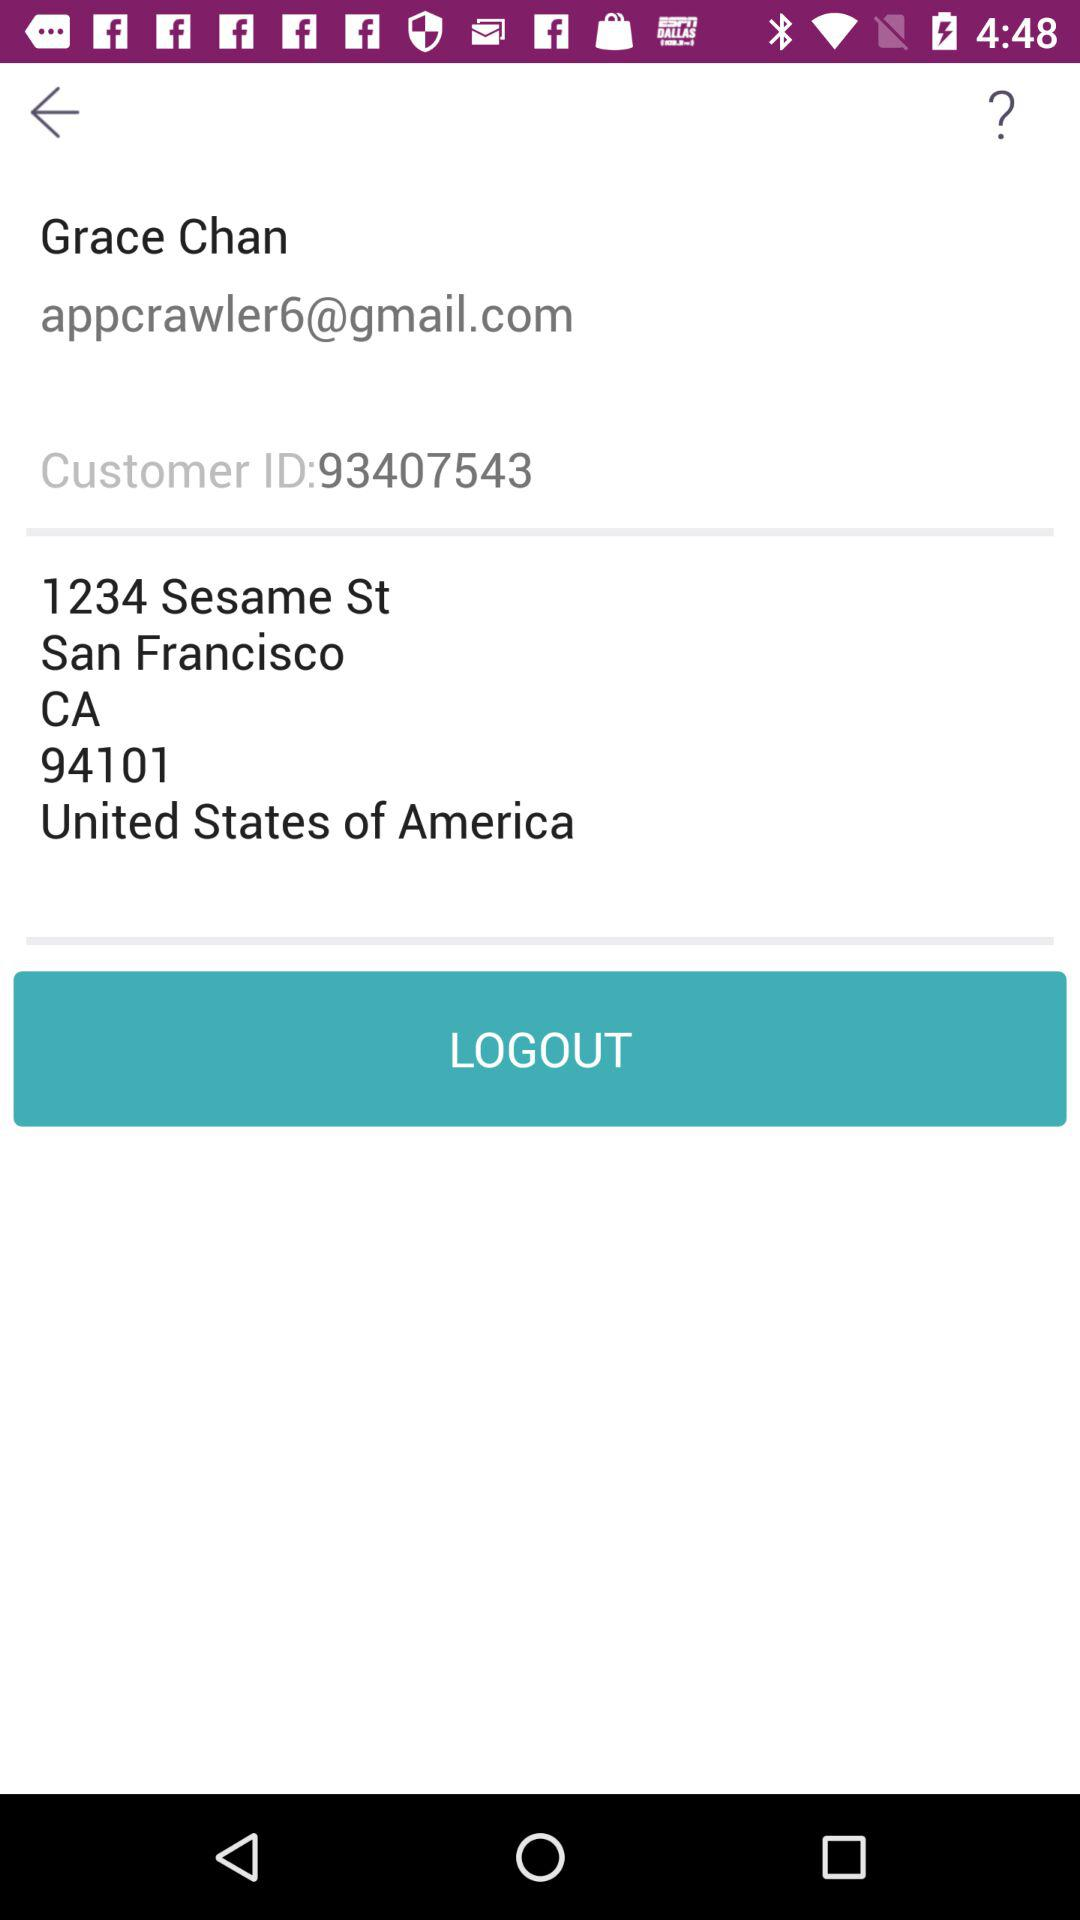What is the user's address? The user's address is 1234 Sesame St, San Francisco, CA 94101, United States of America. 